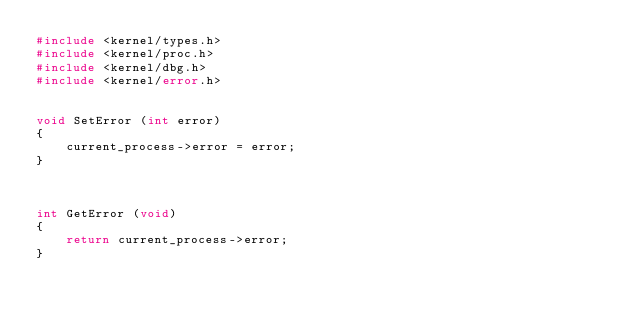Convert code to text. <code><loc_0><loc_0><loc_500><loc_500><_C_>#include <kernel/types.h>
#include <kernel/proc.h>
#include <kernel/dbg.h>
#include <kernel/error.h>


void SetError (int error)
{
	current_process->error = error;
}



int GetError (void)
{
	return current_process->error;
}
</code> 